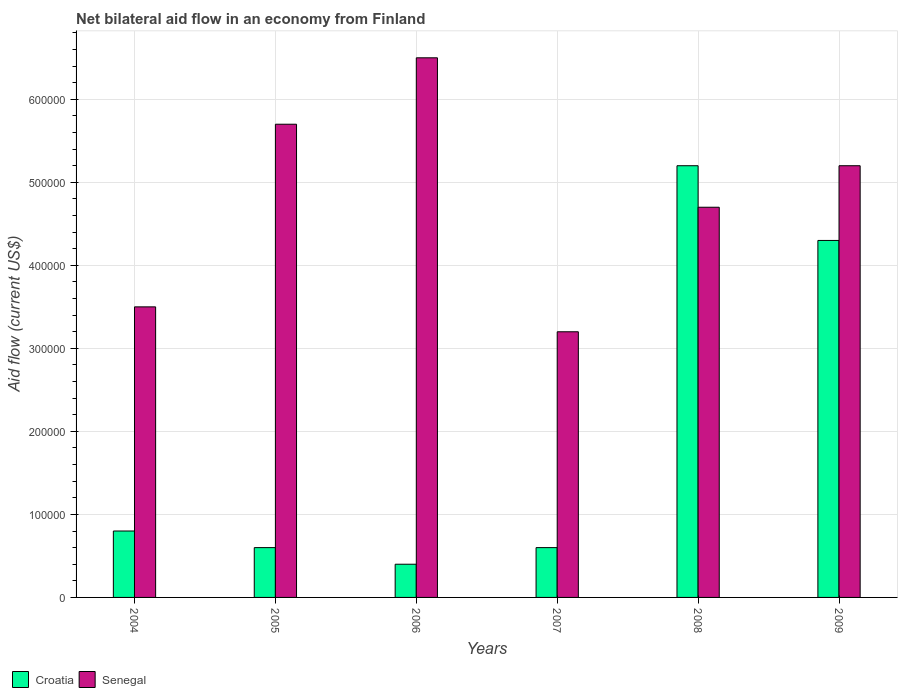Are the number of bars per tick equal to the number of legend labels?
Make the answer very short. Yes. How many bars are there on the 6th tick from the left?
Provide a short and direct response. 2. What is the label of the 1st group of bars from the left?
Provide a short and direct response. 2004. What is the net bilateral aid flow in Senegal in 2006?
Keep it short and to the point. 6.50e+05. Across all years, what is the maximum net bilateral aid flow in Senegal?
Your answer should be very brief. 6.50e+05. In which year was the net bilateral aid flow in Croatia maximum?
Offer a terse response. 2008. In which year was the net bilateral aid flow in Senegal minimum?
Your answer should be very brief. 2007. What is the total net bilateral aid flow in Croatia in the graph?
Offer a very short reply. 1.19e+06. What is the average net bilateral aid flow in Croatia per year?
Offer a terse response. 1.98e+05. In the year 2008, what is the difference between the net bilateral aid flow in Croatia and net bilateral aid flow in Senegal?
Provide a short and direct response. 5.00e+04. What is the ratio of the net bilateral aid flow in Senegal in 2005 to that in 2006?
Your response must be concise. 0.88. Is the difference between the net bilateral aid flow in Croatia in 2008 and 2009 greater than the difference between the net bilateral aid flow in Senegal in 2008 and 2009?
Provide a short and direct response. Yes. What does the 2nd bar from the left in 2009 represents?
Keep it short and to the point. Senegal. What does the 2nd bar from the right in 2006 represents?
Make the answer very short. Croatia. How many bars are there?
Give a very brief answer. 12. Are all the bars in the graph horizontal?
Ensure brevity in your answer.  No. Are the values on the major ticks of Y-axis written in scientific E-notation?
Ensure brevity in your answer.  No. Does the graph contain any zero values?
Your response must be concise. No. How many legend labels are there?
Your answer should be compact. 2. What is the title of the graph?
Your answer should be compact. Net bilateral aid flow in an economy from Finland. What is the label or title of the X-axis?
Offer a very short reply. Years. What is the Aid flow (current US$) in Croatia in 2005?
Keep it short and to the point. 6.00e+04. What is the Aid flow (current US$) in Senegal in 2005?
Ensure brevity in your answer.  5.70e+05. What is the Aid flow (current US$) of Senegal in 2006?
Your answer should be compact. 6.50e+05. What is the Aid flow (current US$) of Croatia in 2007?
Make the answer very short. 6.00e+04. What is the Aid flow (current US$) in Croatia in 2008?
Offer a very short reply. 5.20e+05. What is the Aid flow (current US$) in Croatia in 2009?
Offer a very short reply. 4.30e+05. What is the Aid flow (current US$) of Senegal in 2009?
Offer a very short reply. 5.20e+05. Across all years, what is the maximum Aid flow (current US$) of Croatia?
Make the answer very short. 5.20e+05. Across all years, what is the maximum Aid flow (current US$) in Senegal?
Give a very brief answer. 6.50e+05. Across all years, what is the minimum Aid flow (current US$) in Senegal?
Your response must be concise. 3.20e+05. What is the total Aid flow (current US$) in Croatia in the graph?
Offer a very short reply. 1.19e+06. What is the total Aid flow (current US$) in Senegal in the graph?
Provide a succinct answer. 2.88e+06. What is the difference between the Aid flow (current US$) of Croatia in 2004 and that in 2006?
Provide a short and direct response. 4.00e+04. What is the difference between the Aid flow (current US$) in Senegal in 2004 and that in 2007?
Your response must be concise. 3.00e+04. What is the difference between the Aid flow (current US$) in Croatia in 2004 and that in 2008?
Ensure brevity in your answer.  -4.40e+05. What is the difference between the Aid flow (current US$) in Croatia in 2004 and that in 2009?
Your answer should be compact. -3.50e+05. What is the difference between the Aid flow (current US$) in Senegal in 2004 and that in 2009?
Your answer should be compact. -1.70e+05. What is the difference between the Aid flow (current US$) of Croatia in 2005 and that in 2006?
Your answer should be compact. 2.00e+04. What is the difference between the Aid flow (current US$) of Senegal in 2005 and that in 2006?
Give a very brief answer. -8.00e+04. What is the difference between the Aid flow (current US$) of Croatia in 2005 and that in 2008?
Give a very brief answer. -4.60e+05. What is the difference between the Aid flow (current US$) in Senegal in 2005 and that in 2008?
Keep it short and to the point. 1.00e+05. What is the difference between the Aid flow (current US$) of Croatia in 2005 and that in 2009?
Provide a short and direct response. -3.70e+05. What is the difference between the Aid flow (current US$) of Croatia in 2006 and that in 2007?
Your response must be concise. -2.00e+04. What is the difference between the Aid flow (current US$) of Senegal in 2006 and that in 2007?
Ensure brevity in your answer.  3.30e+05. What is the difference between the Aid flow (current US$) in Croatia in 2006 and that in 2008?
Make the answer very short. -4.80e+05. What is the difference between the Aid flow (current US$) in Croatia in 2006 and that in 2009?
Your answer should be very brief. -3.90e+05. What is the difference between the Aid flow (current US$) of Senegal in 2006 and that in 2009?
Keep it short and to the point. 1.30e+05. What is the difference between the Aid flow (current US$) in Croatia in 2007 and that in 2008?
Offer a terse response. -4.60e+05. What is the difference between the Aid flow (current US$) of Senegal in 2007 and that in 2008?
Provide a short and direct response. -1.50e+05. What is the difference between the Aid flow (current US$) of Croatia in 2007 and that in 2009?
Give a very brief answer. -3.70e+05. What is the difference between the Aid flow (current US$) of Senegal in 2007 and that in 2009?
Provide a short and direct response. -2.00e+05. What is the difference between the Aid flow (current US$) of Croatia in 2008 and that in 2009?
Make the answer very short. 9.00e+04. What is the difference between the Aid flow (current US$) of Senegal in 2008 and that in 2009?
Your response must be concise. -5.00e+04. What is the difference between the Aid flow (current US$) of Croatia in 2004 and the Aid flow (current US$) of Senegal in 2005?
Offer a terse response. -4.90e+05. What is the difference between the Aid flow (current US$) of Croatia in 2004 and the Aid flow (current US$) of Senegal in 2006?
Your response must be concise. -5.70e+05. What is the difference between the Aid flow (current US$) in Croatia in 2004 and the Aid flow (current US$) in Senegal in 2007?
Make the answer very short. -2.40e+05. What is the difference between the Aid flow (current US$) in Croatia in 2004 and the Aid flow (current US$) in Senegal in 2008?
Ensure brevity in your answer.  -3.90e+05. What is the difference between the Aid flow (current US$) of Croatia in 2004 and the Aid flow (current US$) of Senegal in 2009?
Offer a terse response. -4.40e+05. What is the difference between the Aid flow (current US$) in Croatia in 2005 and the Aid flow (current US$) in Senegal in 2006?
Ensure brevity in your answer.  -5.90e+05. What is the difference between the Aid flow (current US$) of Croatia in 2005 and the Aid flow (current US$) of Senegal in 2008?
Offer a terse response. -4.10e+05. What is the difference between the Aid flow (current US$) of Croatia in 2005 and the Aid flow (current US$) of Senegal in 2009?
Your answer should be very brief. -4.60e+05. What is the difference between the Aid flow (current US$) of Croatia in 2006 and the Aid flow (current US$) of Senegal in 2007?
Your answer should be very brief. -2.80e+05. What is the difference between the Aid flow (current US$) of Croatia in 2006 and the Aid flow (current US$) of Senegal in 2008?
Give a very brief answer. -4.30e+05. What is the difference between the Aid flow (current US$) of Croatia in 2006 and the Aid flow (current US$) of Senegal in 2009?
Provide a short and direct response. -4.80e+05. What is the difference between the Aid flow (current US$) in Croatia in 2007 and the Aid flow (current US$) in Senegal in 2008?
Your answer should be very brief. -4.10e+05. What is the difference between the Aid flow (current US$) in Croatia in 2007 and the Aid flow (current US$) in Senegal in 2009?
Make the answer very short. -4.60e+05. What is the average Aid flow (current US$) in Croatia per year?
Provide a succinct answer. 1.98e+05. What is the average Aid flow (current US$) in Senegal per year?
Your response must be concise. 4.80e+05. In the year 2004, what is the difference between the Aid flow (current US$) in Croatia and Aid flow (current US$) in Senegal?
Make the answer very short. -2.70e+05. In the year 2005, what is the difference between the Aid flow (current US$) in Croatia and Aid flow (current US$) in Senegal?
Give a very brief answer. -5.10e+05. In the year 2006, what is the difference between the Aid flow (current US$) of Croatia and Aid flow (current US$) of Senegal?
Give a very brief answer. -6.10e+05. In the year 2009, what is the difference between the Aid flow (current US$) in Croatia and Aid flow (current US$) in Senegal?
Your answer should be compact. -9.00e+04. What is the ratio of the Aid flow (current US$) of Croatia in 2004 to that in 2005?
Offer a very short reply. 1.33. What is the ratio of the Aid flow (current US$) of Senegal in 2004 to that in 2005?
Provide a short and direct response. 0.61. What is the ratio of the Aid flow (current US$) of Senegal in 2004 to that in 2006?
Keep it short and to the point. 0.54. What is the ratio of the Aid flow (current US$) in Croatia in 2004 to that in 2007?
Keep it short and to the point. 1.33. What is the ratio of the Aid flow (current US$) in Senegal in 2004 to that in 2007?
Your response must be concise. 1.09. What is the ratio of the Aid flow (current US$) in Croatia in 2004 to that in 2008?
Give a very brief answer. 0.15. What is the ratio of the Aid flow (current US$) of Senegal in 2004 to that in 2008?
Your response must be concise. 0.74. What is the ratio of the Aid flow (current US$) of Croatia in 2004 to that in 2009?
Give a very brief answer. 0.19. What is the ratio of the Aid flow (current US$) in Senegal in 2004 to that in 2009?
Your answer should be very brief. 0.67. What is the ratio of the Aid flow (current US$) in Croatia in 2005 to that in 2006?
Offer a terse response. 1.5. What is the ratio of the Aid flow (current US$) in Senegal in 2005 to that in 2006?
Provide a succinct answer. 0.88. What is the ratio of the Aid flow (current US$) in Croatia in 2005 to that in 2007?
Provide a short and direct response. 1. What is the ratio of the Aid flow (current US$) in Senegal in 2005 to that in 2007?
Give a very brief answer. 1.78. What is the ratio of the Aid flow (current US$) of Croatia in 2005 to that in 2008?
Ensure brevity in your answer.  0.12. What is the ratio of the Aid flow (current US$) of Senegal in 2005 to that in 2008?
Offer a terse response. 1.21. What is the ratio of the Aid flow (current US$) of Croatia in 2005 to that in 2009?
Provide a short and direct response. 0.14. What is the ratio of the Aid flow (current US$) of Senegal in 2005 to that in 2009?
Make the answer very short. 1.1. What is the ratio of the Aid flow (current US$) of Croatia in 2006 to that in 2007?
Your answer should be compact. 0.67. What is the ratio of the Aid flow (current US$) in Senegal in 2006 to that in 2007?
Provide a short and direct response. 2.03. What is the ratio of the Aid flow (current US$) of Croatia in 2006 to that in 2008?
Ensure brevity in your answer.  0.08. What is the ratio of the Aid flow (current US$) of Senegal in 2006 to that in 2008?
Give a very brief answer. 1.38. What is the ratio of the Aid flow (current US$) of Croatia in 2006 to that in 2009?
Make the answer very short. 0.09. What is the ratio of the Aid flow (current US$) in Senegal in 2006 to that in 2009?
Give a very brief answer. 1.25. What is the ratio of the Aid flow (current US$) of Croatia in 2007 to that in 2008?
Give a very brief answer. 0.12. What is the ratio of the Aid flow (current US$) of Senegal in 2007 to that in 2008?
Provide a succinct answer. 0.68. What is the ratio of the Aid flow (current US$) in Croatia in 2007 to that in 2009?
Your answer should be very brief. 0.14. What is the ratio of the Aid flow (current US$) of Senegal in 2007 to that in 2009?
Provide a succinct answer. 0.62. What is the ratio of the Aid flow (current US$) of Croatia in 2008 to that in 2009?
Your answer should be compact. 1.21. What is the ratio of the Aid flow (current US$) of Senegal in 2008 to that in 2009?
Your response must be concise. 0.9. What is the difference between the highest and the lowest Aid flow (current US$) in Senegal?
Your answer should be very brief. 3.30e+05. 